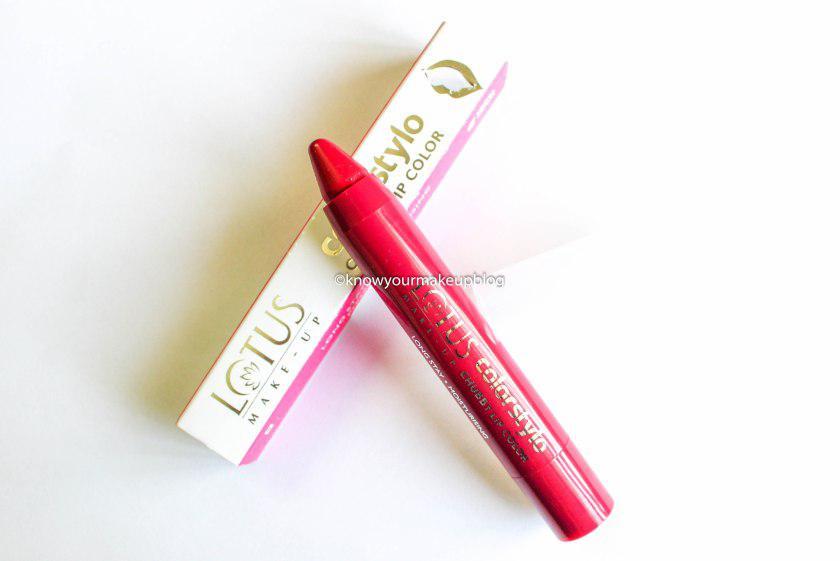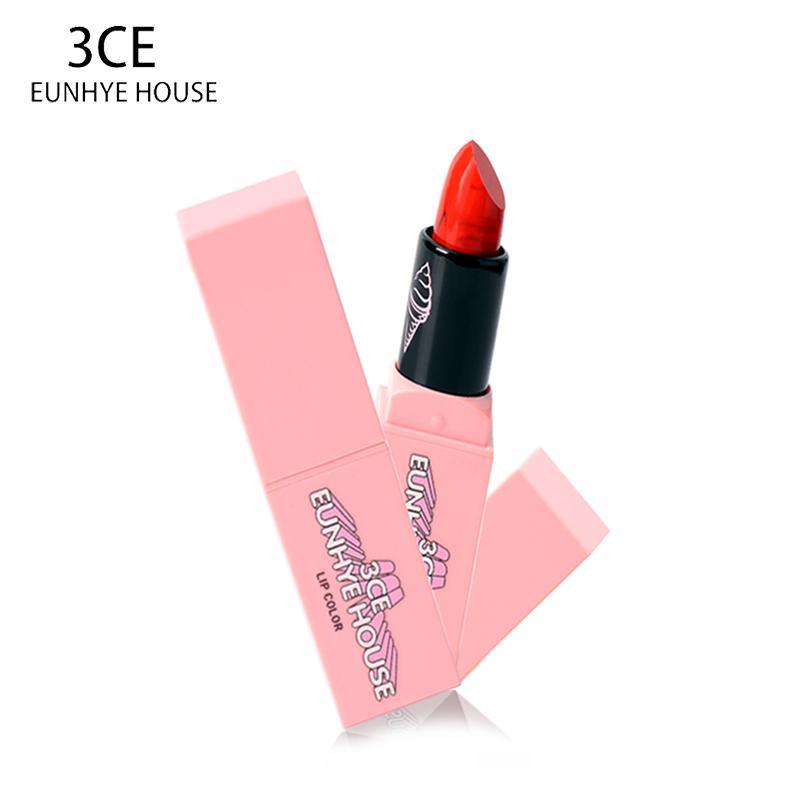The first image is the image on the left, the second image is the image on the right. Analyze the images presented: Is the assertion "In one of the photos, there are two sticks of lipstick crossing each other." valid? Answer yes or no. No. The first image is the image on the left, the second image is the image on the right. For the images displayed, is the sentence "There are 2 lipstick pencils crossed neatly like an X and one has the cap off." factually correct? Answer yes or no. No. 